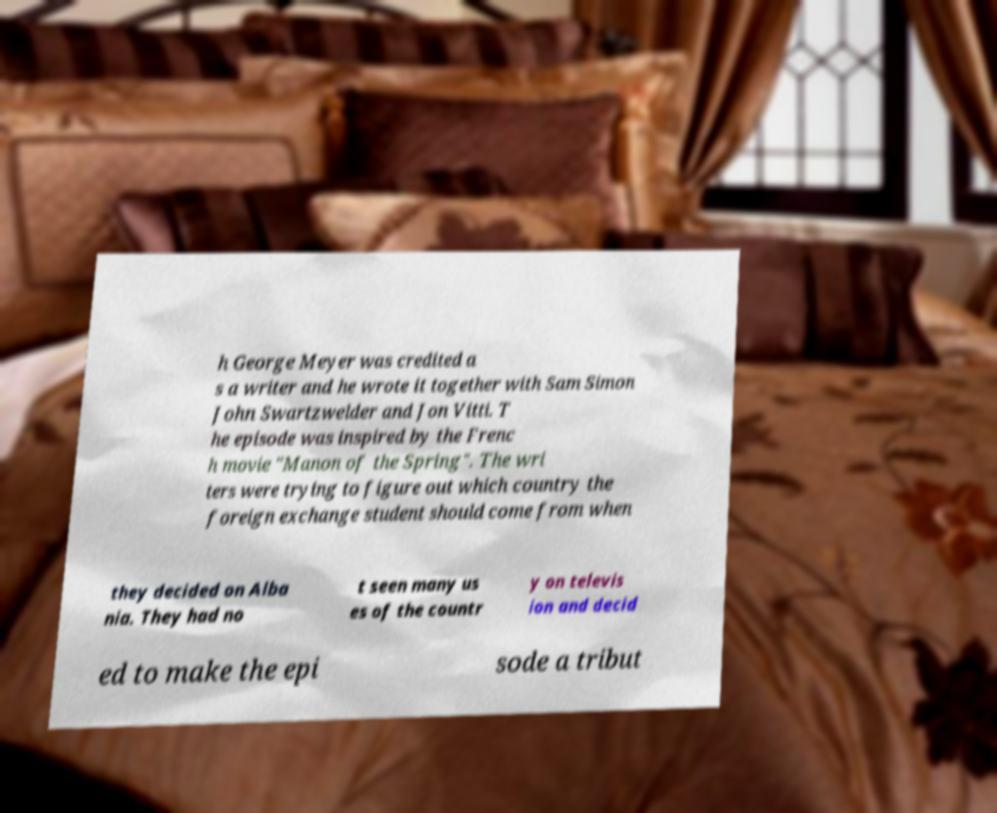There's text embedded in this image that I need extracted. Can you transcribe it verbatim? h George Meyer was credited a s a writer and he wrote it together with Sam Simon John Swartzwelder and Jon Vitti. T he episode was inspired by the Frenc h movie "Manon of the Spring". The wri ters were trying to figure out which country the foreign exchange student should come from when they decided on Alba nia. They had no t seen many us es of the countr y on televis ion and decid ed to make the epi sode a tribut 